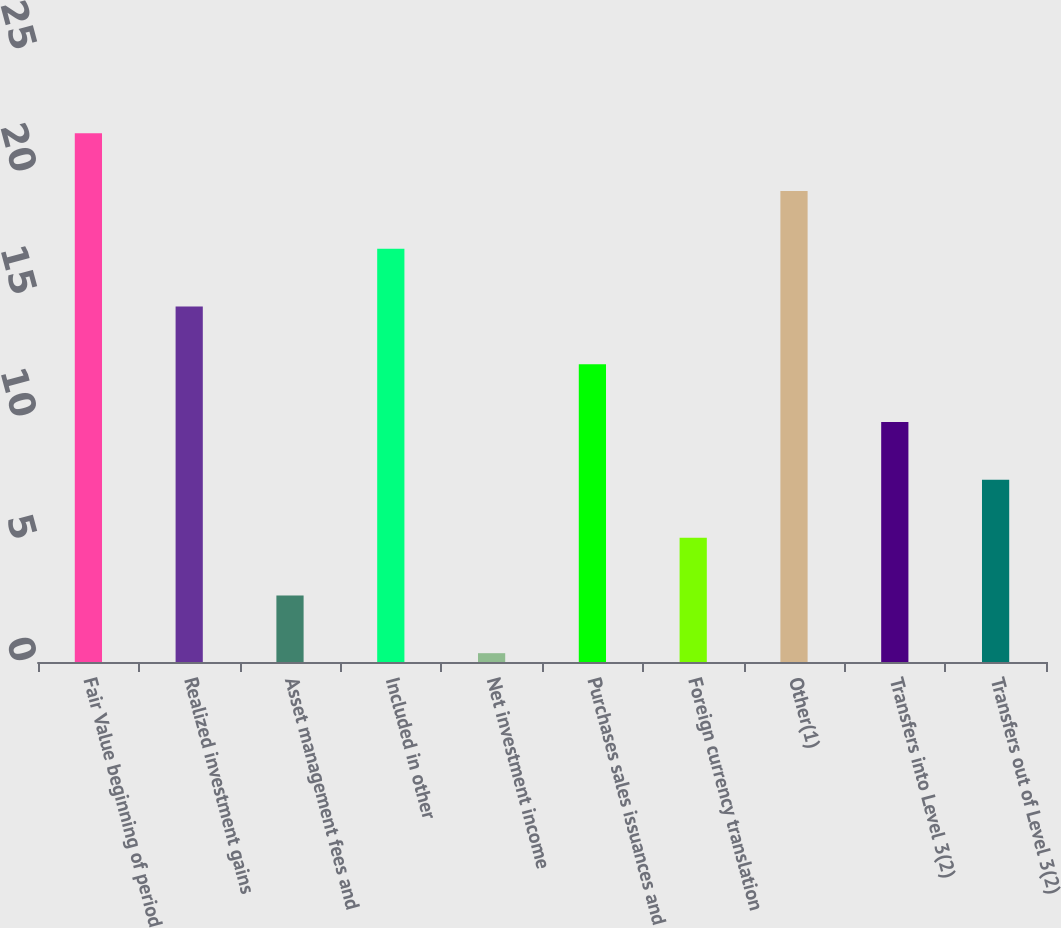Convert chart. <chart><loc_0><loc_0><loc_500><loc_500><bar_chart><fcel>Fair Value beginning of period<fcel>Realized investment gains<fcel>Asset management fees and<fcel>Included in other<fcel>Net investment income<fcel>Purchases sales issuances and<fcel>Foreign currency translation<fcel>Other(1)<fcel>Transfers into Level 3(2)<fcel>Transfers out of Level 3(2)<nl><fcel>21.6<fcel>14.52<fcel>2.72<fcel>16.88<fcel>0.36<fcel>12.16<fcel>5.08<fcel>19.24<fcel>9.8<fcel>7.44<nl></chart> 